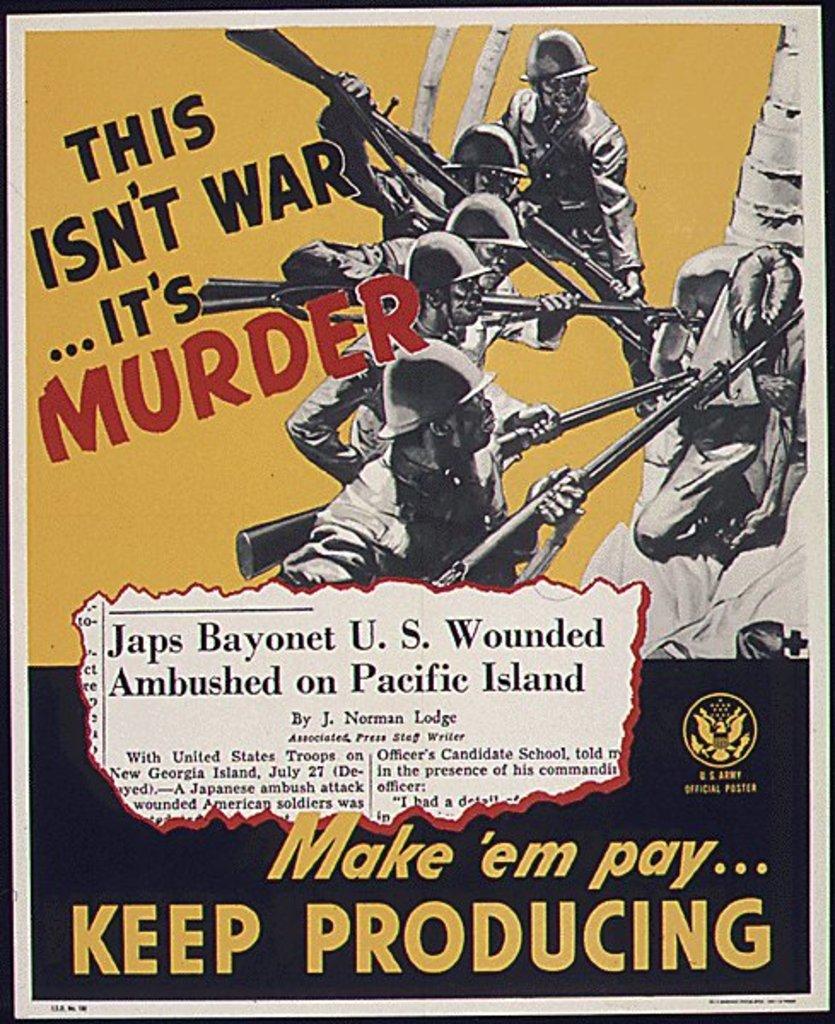What isn't war?
Provide a short and direct response. Murder. They want you to keep what?
Your response must be concise. Producing. 